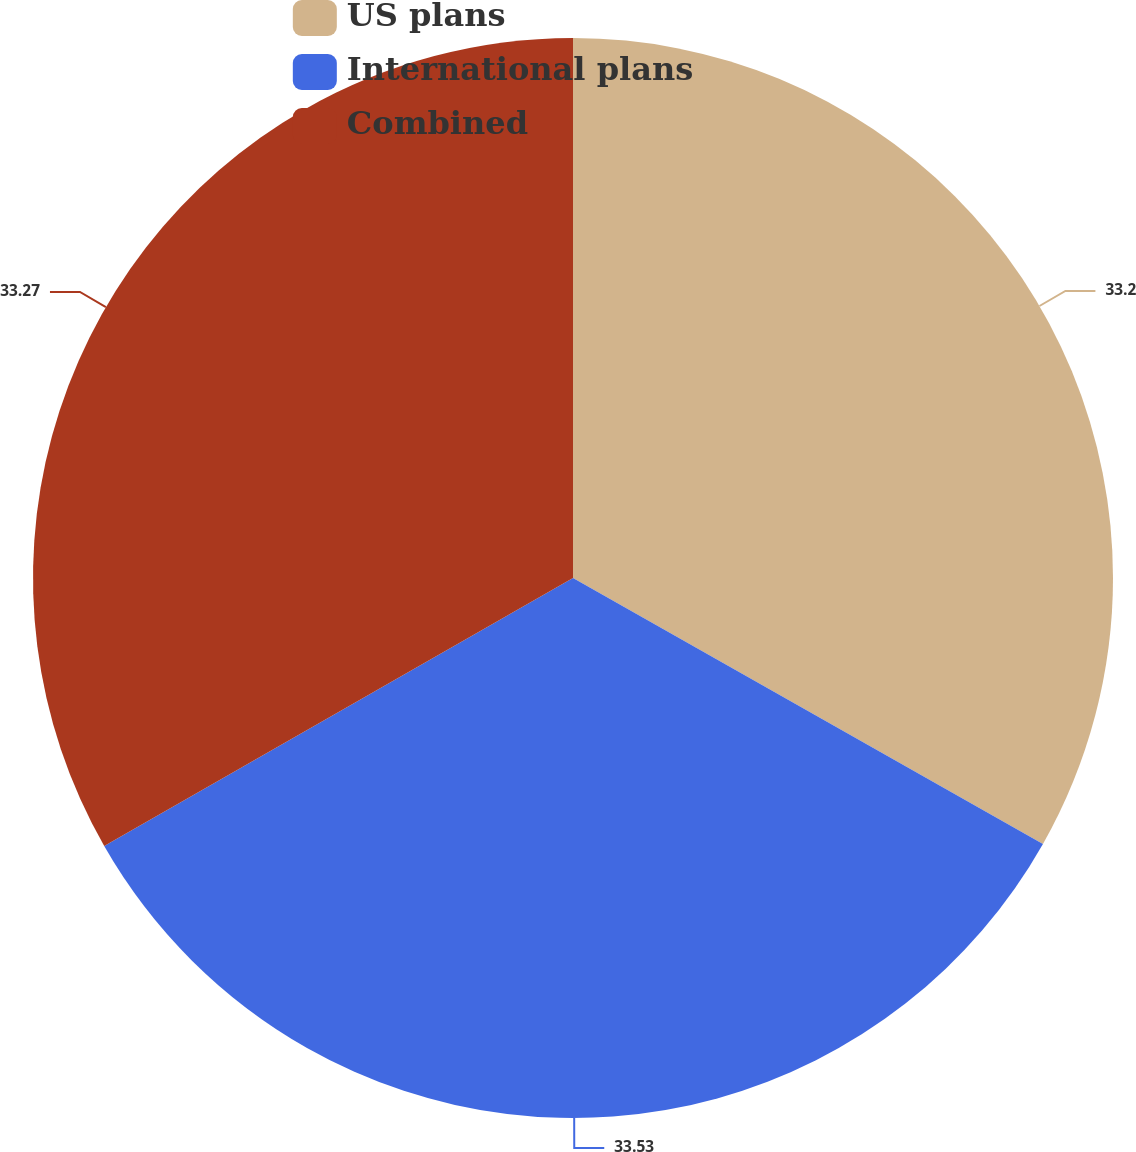Convert chart to OTSL. <chart><loc_0><loc_0><loc_500><loc_500><pie_chart><fcel>US plans<fcel>International plans<fcel>Combined<nl><fcel>33.2%<fcel>33.54%<fcel>33.27%<nl></chart> 